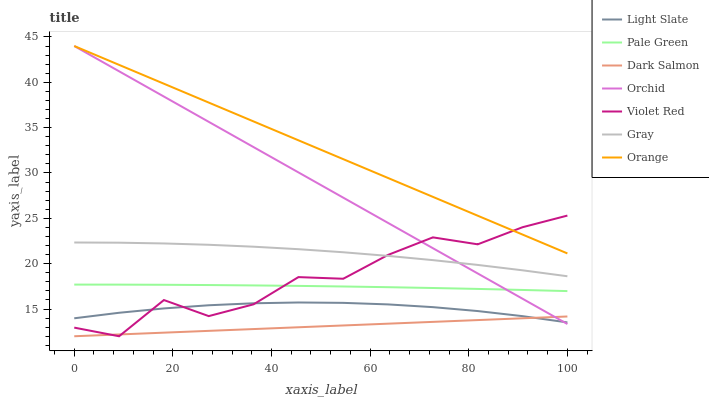Does Dark Salmon have the minimum area under the curve?
Answer yes or no. Yes. Does Orange have the maximum area under the curve?
Answer yes or no. Yes. Does Violet Red have the minimum area under the curve?
Answer yes or no. No. Does Violet Red have the maximum area under the curve?
Answer yes or no. No. Is Dark Salmon the smoothest?
Answer yes or no. Yes. Is Violet Red the roughest?
Answer yes or no. Yes. Is Light Slate the smoothest?
Answer yes or no. No. Is Light Slate the roughest?
Answer yes or no. No. Does Violet Red have the lowest value?
Answer yes or no. Yes. Does Light Slate have the lowest value?
Answer yes or no. No. Does Orchid have the highest value?
Answer yes or no. Yes. Does Violet Red have the highest value?
Answer yes or no. No. Is Pale Green less than Gray?
Answer yes or no. Yes. Is Orange greater than Light Slate?
Answer yes or no. Yes. Does Orchid intersect Light Slate?
Answer yes or no. Yes. Is Orchid less than Light Slate?
Answer yes or no. No. Is Orchid greater than Light Slate?
Answer yes or no. No. Does Pale Green intersect Gray?
Answer yes or no. No. 